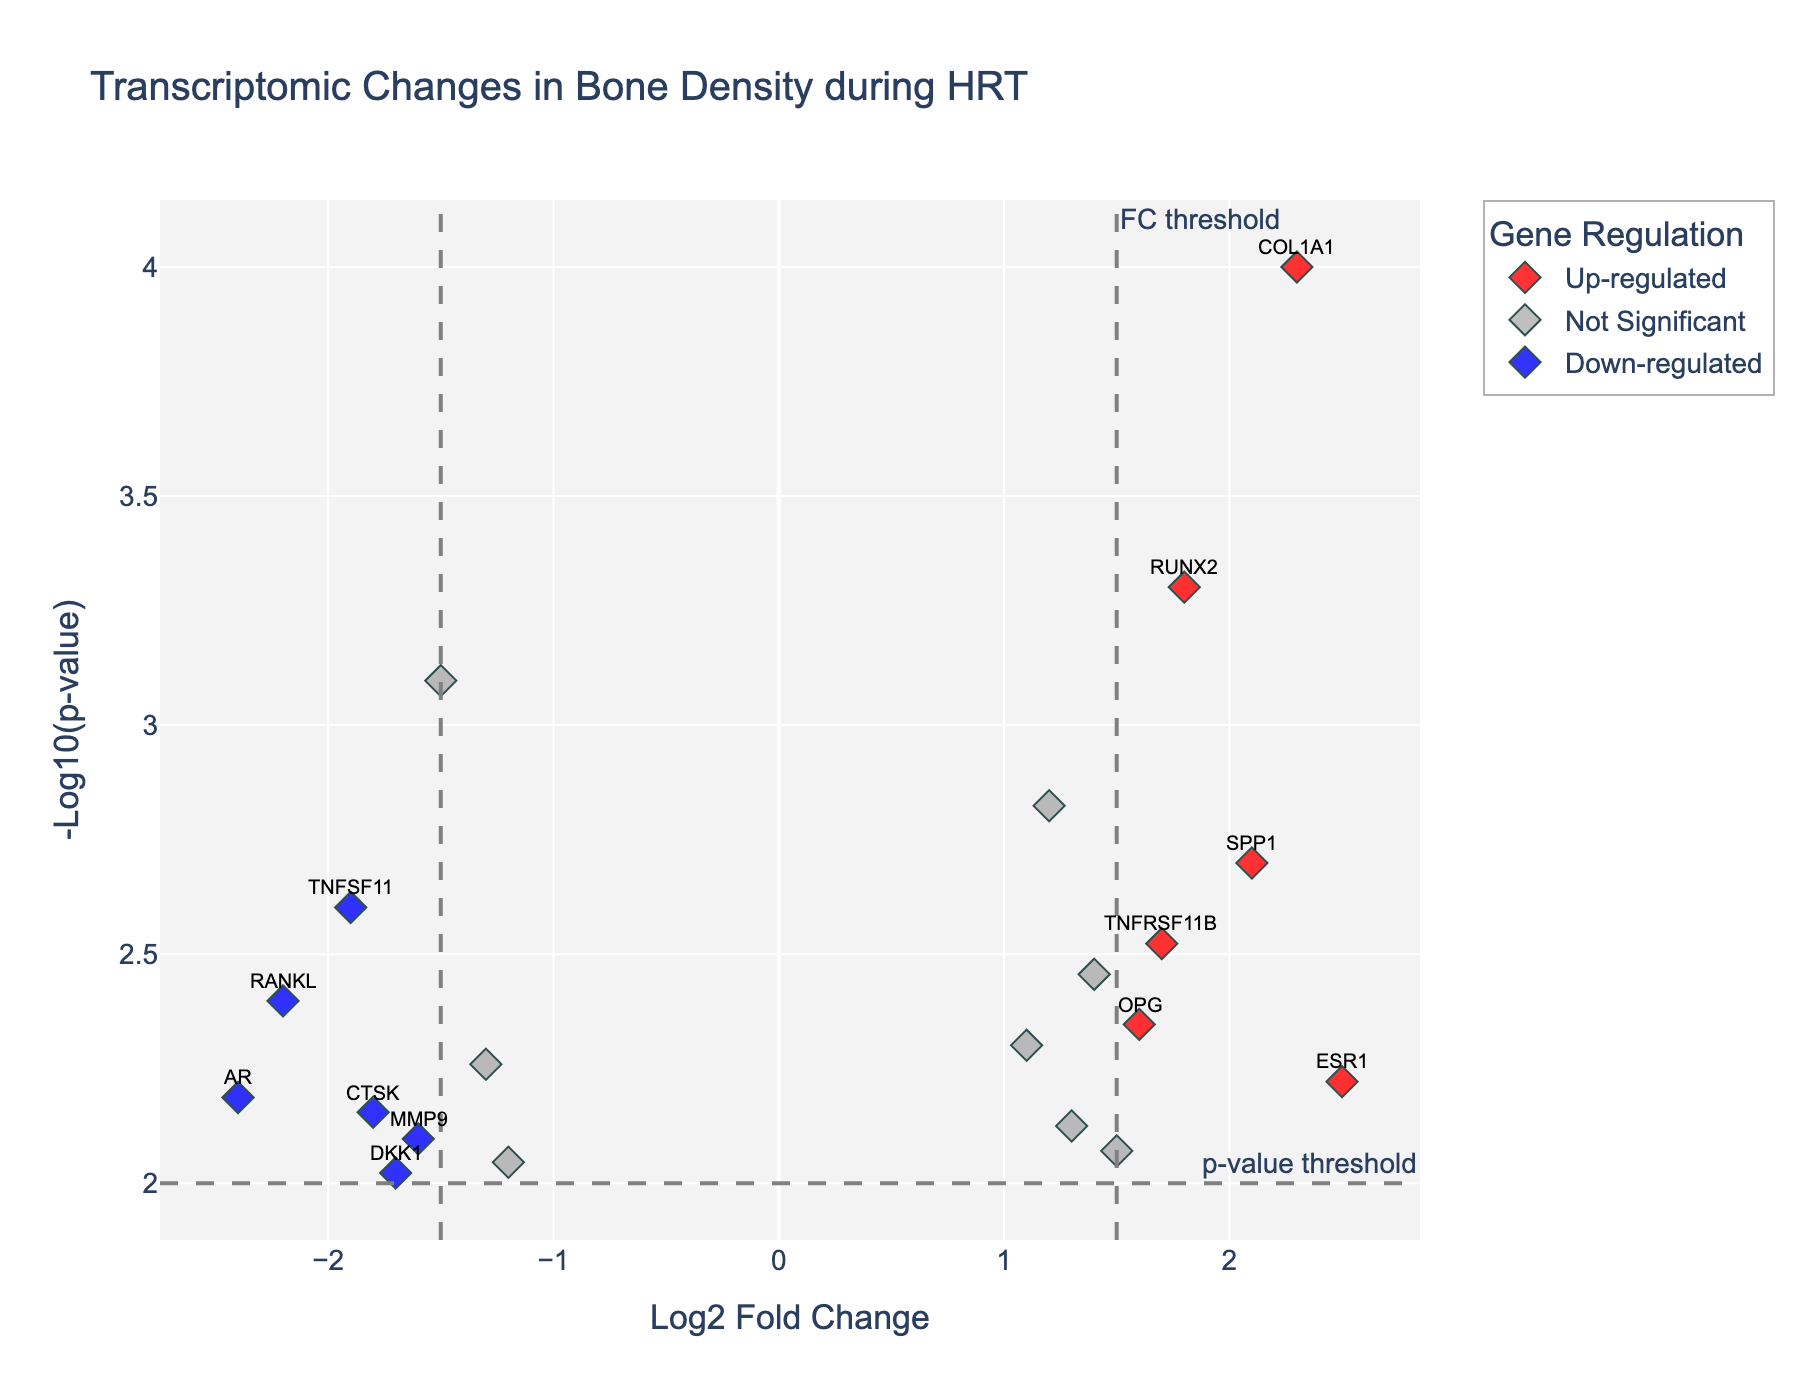What is the title of the figure? The title is usually placed at the top of the figure and summarizes the overall content in a few words. The figure's title is "Transcriptomic Changes in Bone Density during HRT"
Answer: Transcriptomic Changes in Bone Density during HRT What do the x and y axes represent? The x-axis shows the Log2 Fold Change, which indicates the logarithm of gene expression changes. The y-axis represents the -Log10(p-value), which is the negative logarithm of the p-value, indicating statistical significance.
Answer: Log2 Fold Change and -Log10(p-value) Which genes are significantly down-regulated? The significantly down-regulated genes are determined by having a Log2 Fold Change less than -1.5 and a p-value less than 0.01, indicated in blue. By checking these criteria, the genes are RANKL, AR, and TNFSF11.
Answer: RANKL, AR, TNFSF11 What is the color used for up-regulated genes? Colors in the figure indicate different categories. Up-regulated genes are denoted with red coloring.
Answer: Red How many genes have a Log2 Fold Change greater than 2? To find the total number of genes with a Log2 Fold Change greater than 2, check the x-axis for points beyond 2. According to the figure, genes COL1A1, SPP1, and ESR1 meet this criterion.
Answer: 3 Which gene has the highest Log2 Fold Change and what is its value? Identify the point farthest to the right on the x-axis and check the corresponding label and value. According to the figure, ESR1 has the highest Log2 Fold Change of 2.5.
Answer: ESR1, 2.5 What is the p-value threshold represented by the horizontal line, and how is it displayed in the figure? The p-value threshold is indicated by a horizontal dashed line. The value for this threshold is 0.01. The line is annotated as "p-value threshold" on the y-axis.
Answer: 0.01 How many genes are categorized as not significant? Genes categorized as not significant are those that don't meet the thresholds for fold change or p-value. From the figure, they are colored gray. All gray points count as not significant genes. The total count is determined from the data and figure inspection.
Answer: 7 Which gene shows a significant up-regulation and is closest to the p-value threshold? Up-regulated genes are red points above the p-value threshold (dashed line). By comparing the y-axis values, COL1A1 is the closest above this threshold with an -Log10(p-value) near 4.
Answer: COL1A1 How is the fold change threshold represented in the figure? The fold change threshold is indicated by vertical dashed lines that demarcate log2 fold change values of ±1.5 and annotated as "FC threshold" on the x-axis.
Answer: Vertical dashed lines at ±1.5 